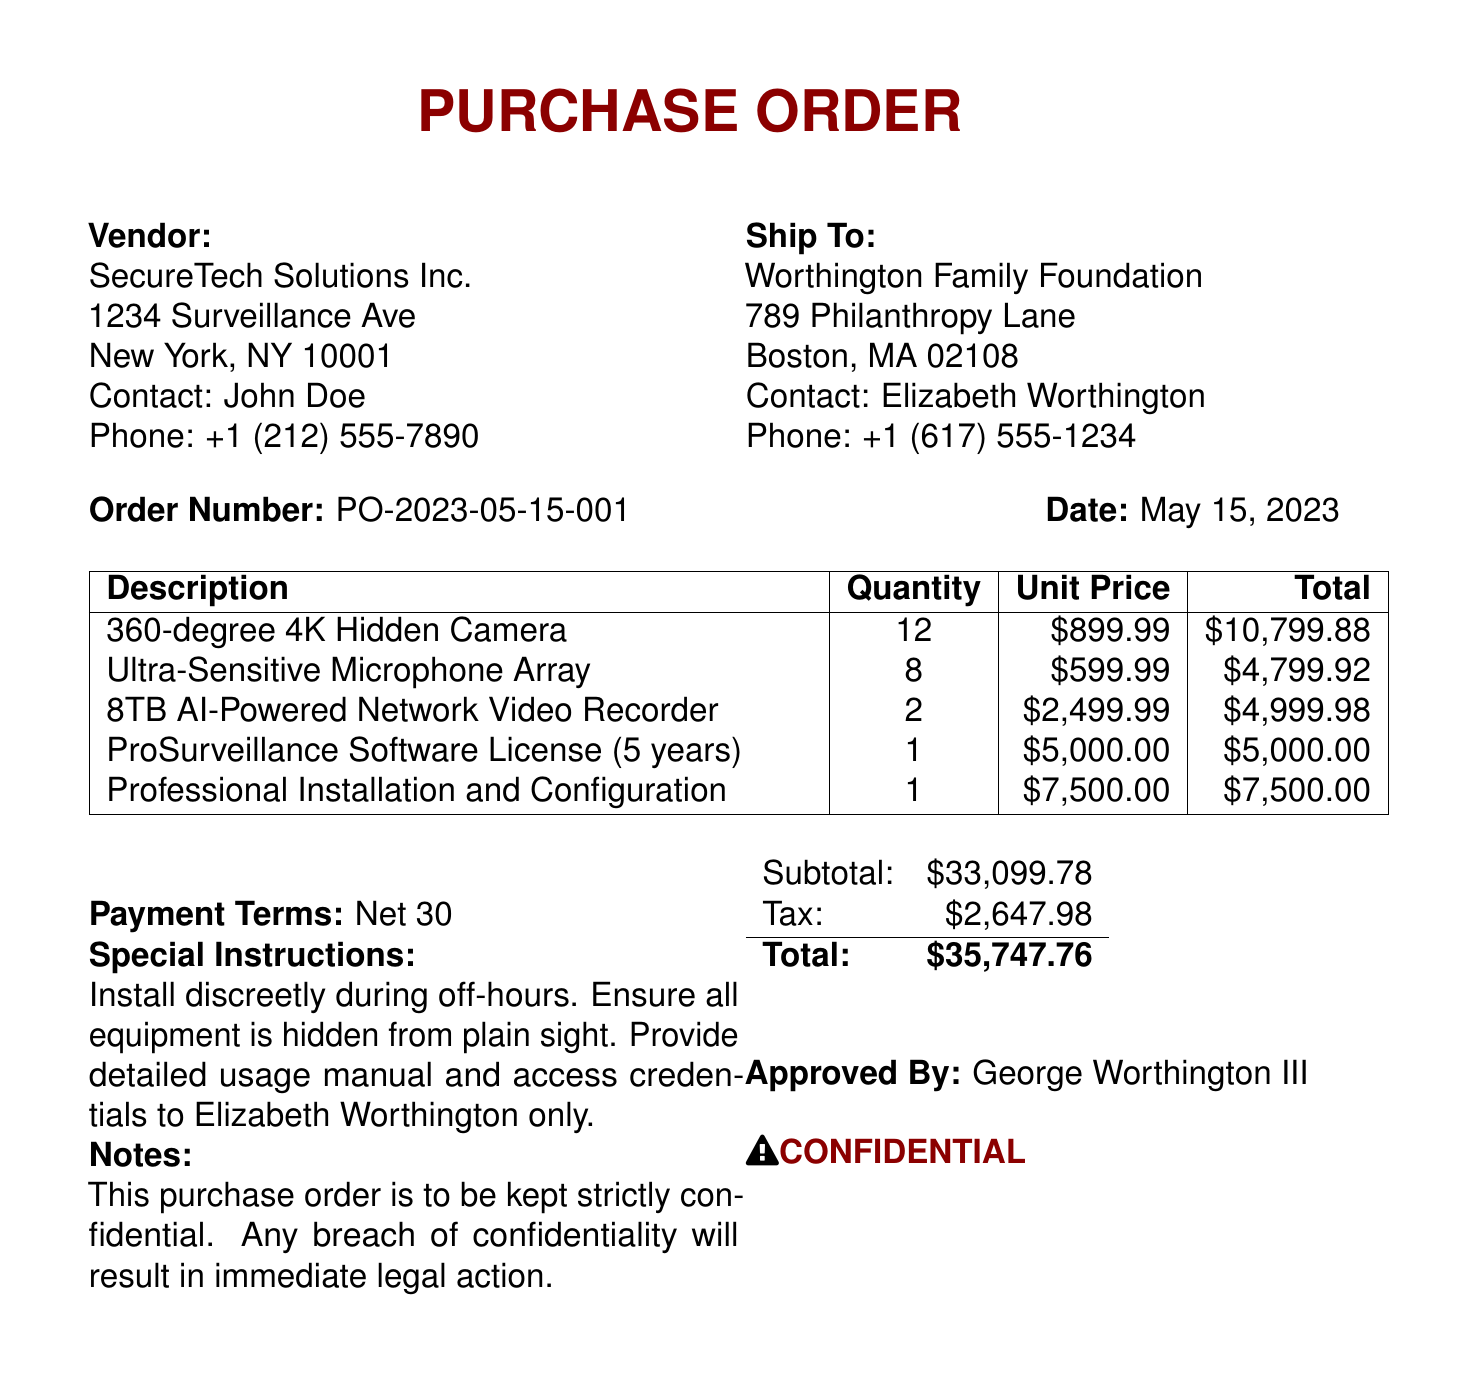what is the order number? The order number is specified in the document as a unique identifier for the transaction.
Answer: PO-2023-05-15-001 what is the total amount of the purchase order? The total amount is the overall cost including subtotal and tax, which is presented toward the end of the document.
Answer: $35,747.76 who approved the purchase order? The document indicates the name of the individual who authorized the purchase, which is included at the bottom.
Answer: George Worthington III how many 360-degree 4K Hidden Cameras were ordered? The quantity of the particular item is listed in the items section of the document.
Answer: 12 what are the payment terms? Payment terms are stated clearly in the document, denoting when payment is expected.
Answer: Net 30 what is the subtotal before tax? The subtotal is detailed in the financial summary portion, providing the total before any tax is added.
Answer: $33,099.78 who is the contact person at the vendor company? The document specifies a contact person for the vendor, which is vital for communication regarding the order.
Answer: John Doe what kind of special instructions were given? Special instructions detail the requirements or requests regarding the handling of the order, mentioned prominently in the document.
Answer: Install discreetly during off-hours. Ensure all equipment is hidden from plain sight. Provide detailed usage manual and access credentials to Elizabeth Worthington only 